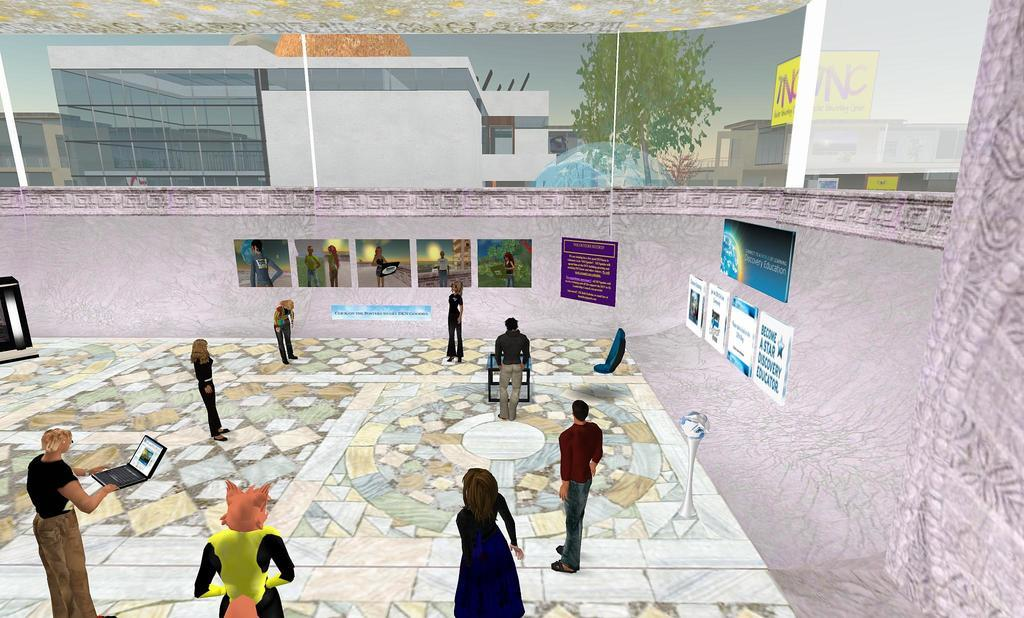What type of image is being described? The image is animated. What can be seen inside the animated image? There is a room in the image. Who or what is present in the room? There is a group of people in the room. What is attached to the walls of the room? There are posters attached to the wall of the room. What brand of toothpaste is being advertised on the posters in the room? There is no toothpaste or advertisement mentioned in the image, as it only describes a room with posters on the walls. 